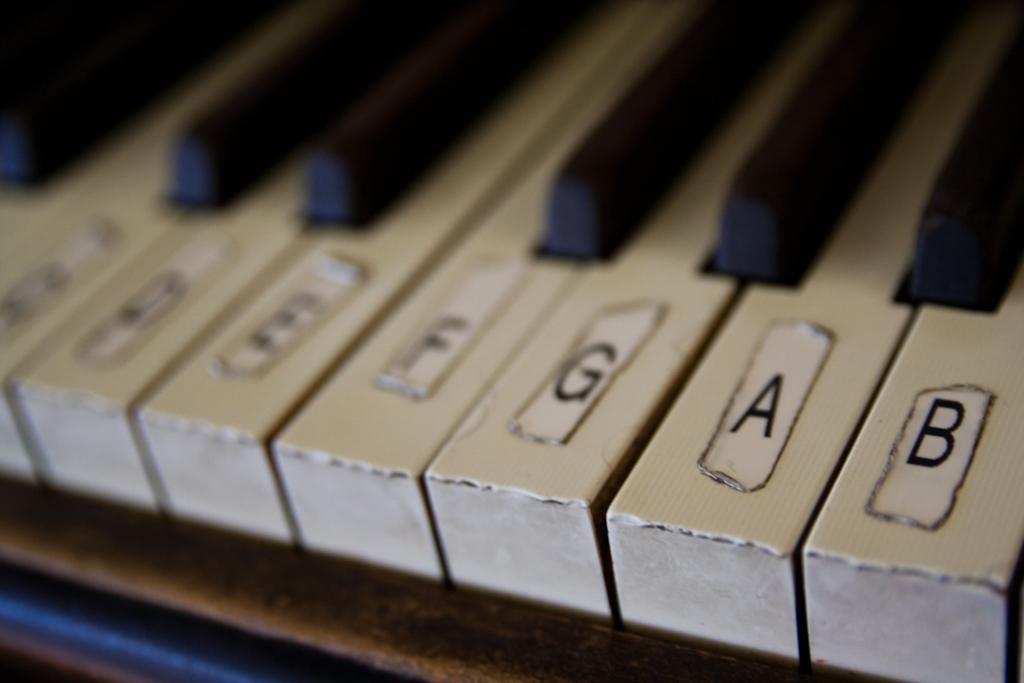What is the main subject of the image? The main subject of the image is a piano. Can you describe the piano in the image? The image is a close view of the piano, so we can see its keys, body, and other details. What type of cakes are being served at the nation's celebration in the image? There is no mention of a nation or celebration in the image, and no cakes are present. 